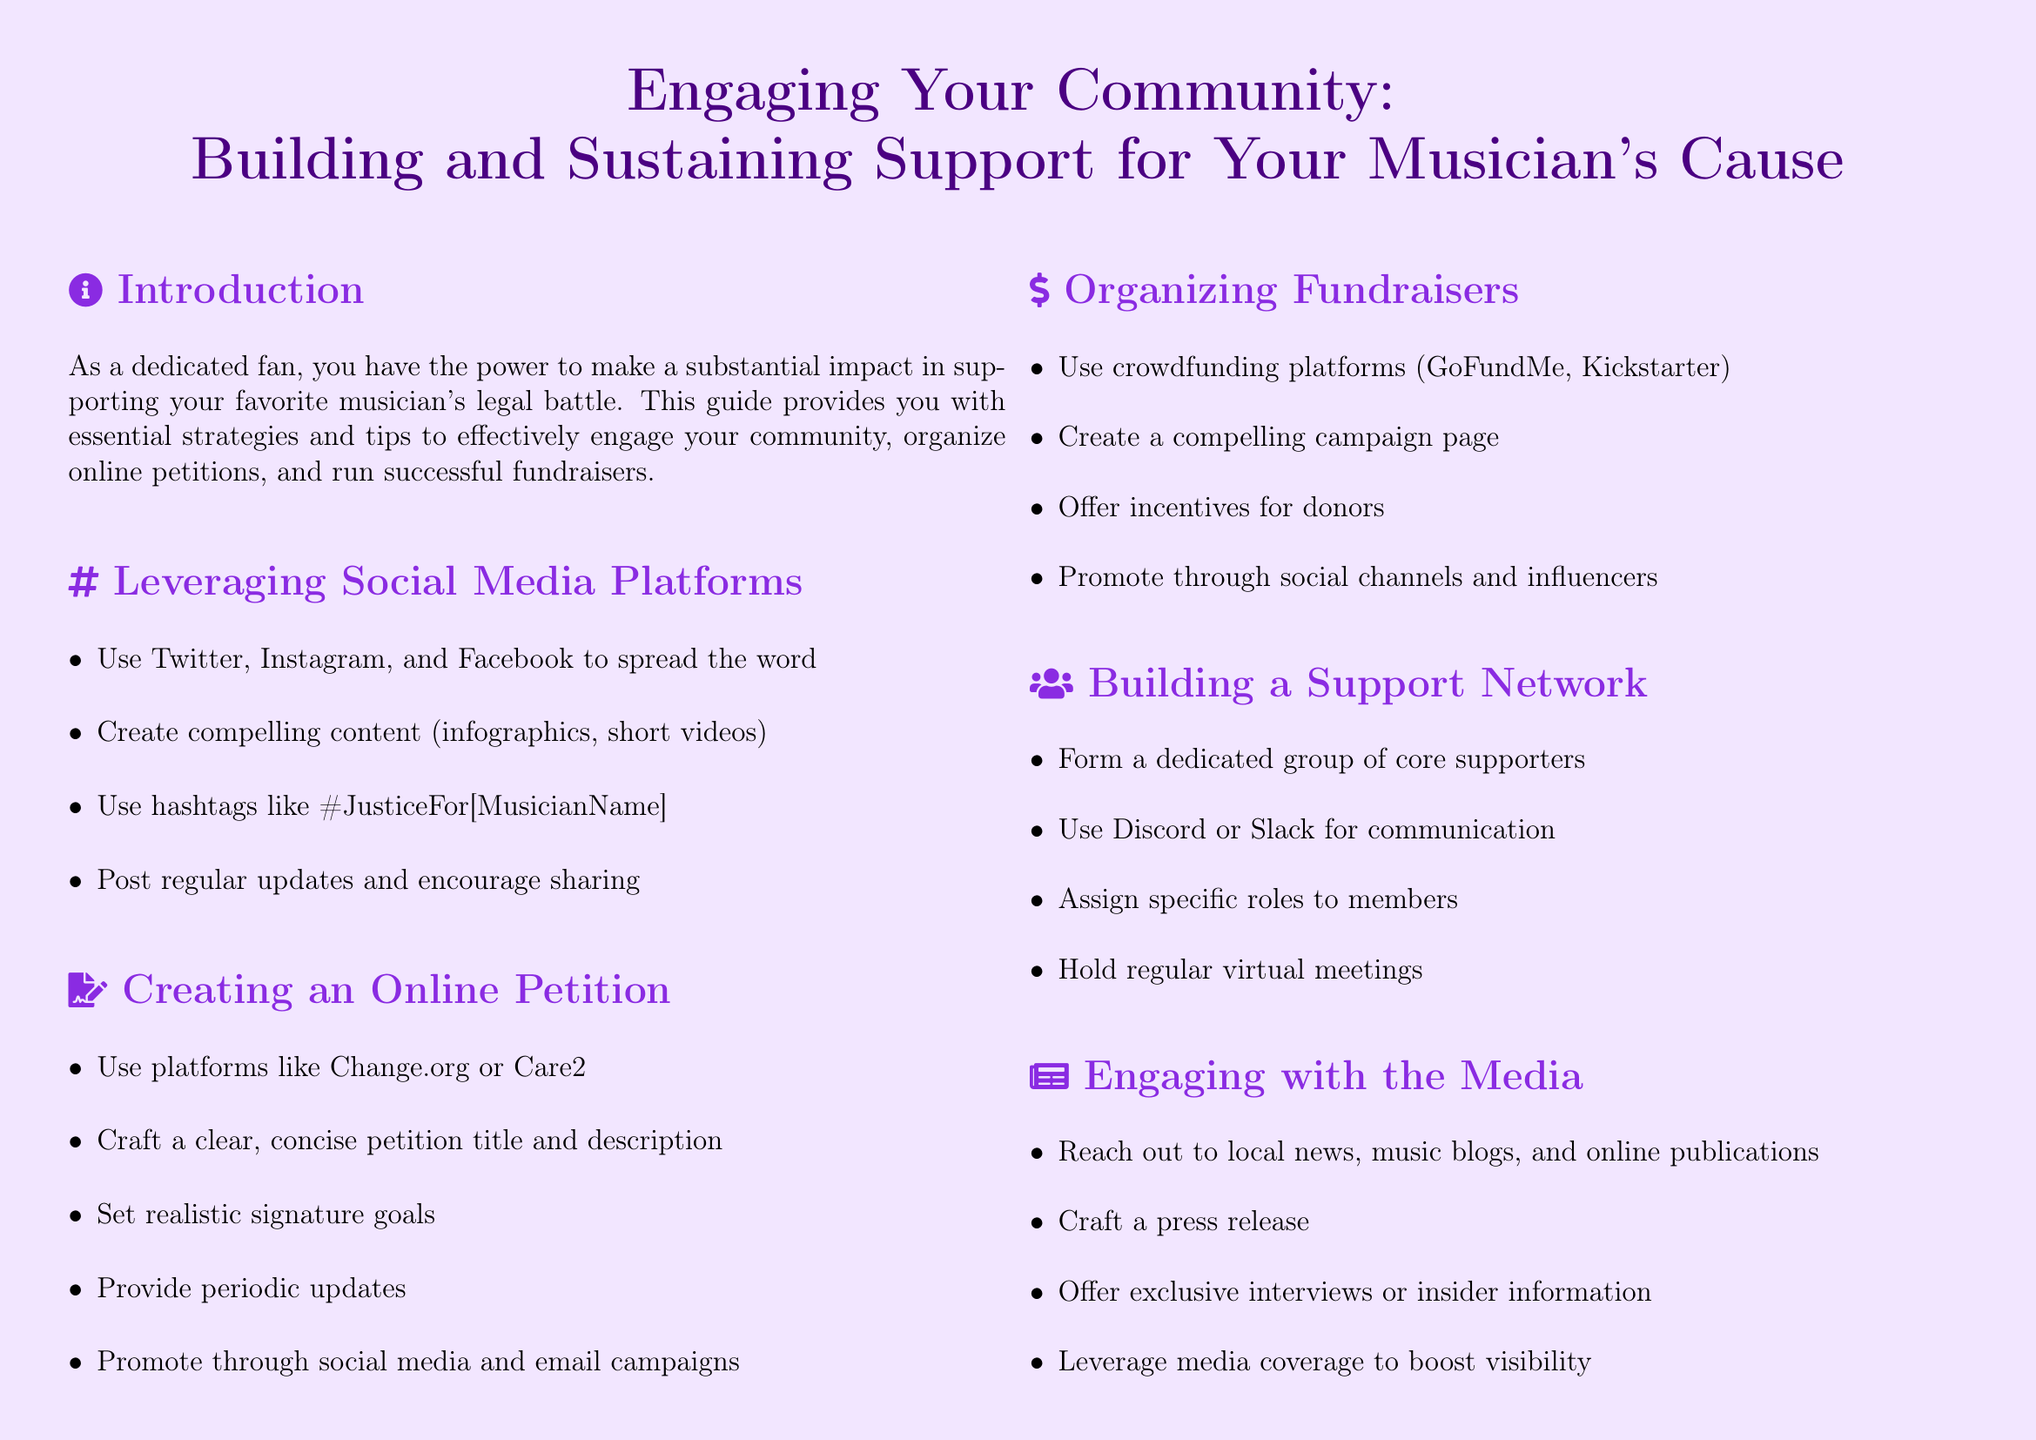What is the purpose of the guide? The guide provides strategies and tips to effectively engage your community and support your musician's legal battle.
Answer: Support musician's legal battle What platforms are suggested for online petitions? The document suggests using platforms like Change.org or Care2 for creating online petitions.
Answer: Change.org, Care2 What is a recommended action to promote fundraisers? The document recommends promoting fundraisers through social channels and influencers.
Answer: Social channels, influencers What is one way to maintain momentum in community engagement? Regularly updating the community on progress is one way to maintain momentum.
Answer: Regular updates How often should virtual meetings be held according to the guide? The guide suggests holding regular virtual meetings for core supporters.
Answer: Regularly What type of content is suggested for social media? The guide suggests creating compelling content such as infographics and short videos for social media.
Answer: Infographics, short videos What is the main focus of the introduction section? The introduction emphasizes the impact that dedicated fans can have in supporting their musician.
Answer: Impact of dedicated fans What should be included in a press release? The document states that a press release should be crafted to reach out to local news and online publications.
Answer: Local news, online publications What is a key strategy for building a support network? A key strategy mentioned is forming a dedicated group of core supporters.
Answer: Core supporters 